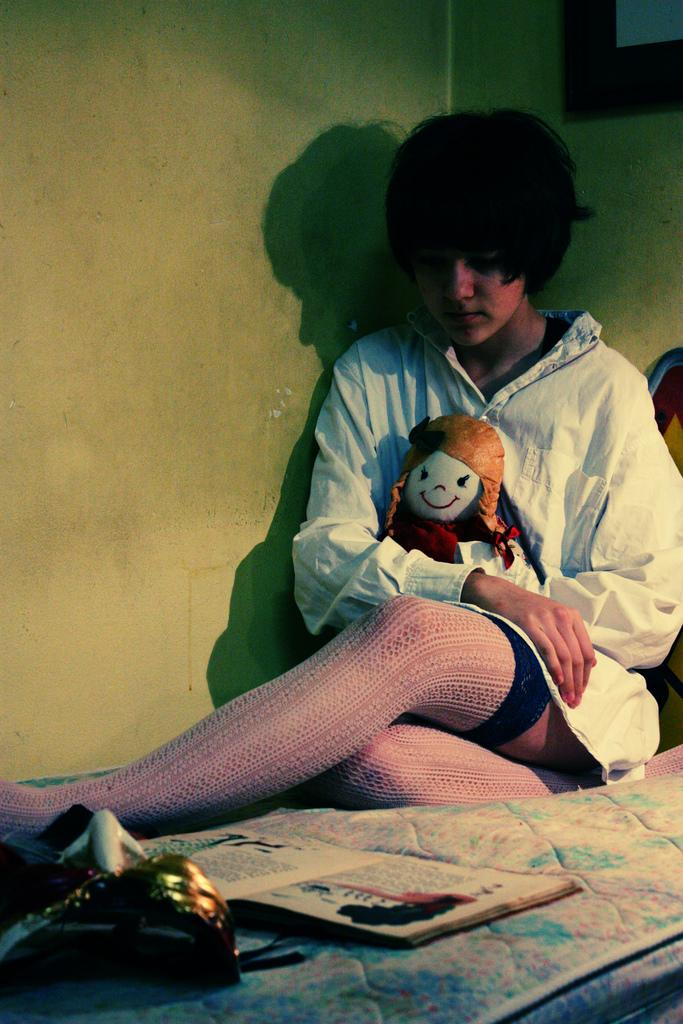What is the person in the image doing? The person is holding a toy in the image. Where is the person sitting? The person is sitting on a surface that resembles a bed. What else can be seen in the image besides the person and the toy? There is a book and other objects in the image. What is visible in the background of the image? There is a wall visible in the image. What direction is the wind blowing in the image? There is no wind present in the image; it is an indoor setting. What type of teeth can be seen in the image? There are no teeth visible in the image. 